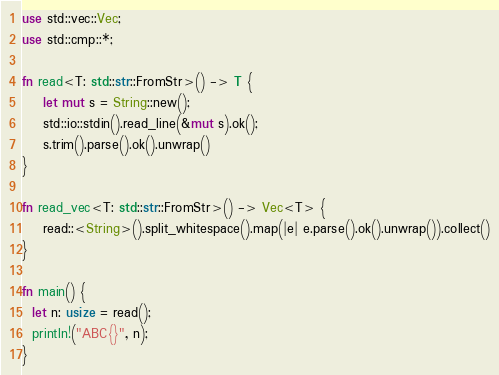<code> <loc_0><loc_0><loc_500><loc_500><_Rust_>use std::vec::Vec;
use std::cmp::*;

fn read<T: std::str::FromStr>() -> T {
    let mut s = String::new();
    std::io::stdin().read_line(&mut s).ok();
    s.trim().parse().ok().unwrap()
}

fn read_vec<T: std::str::FromStr>() -> Vec<T> {
    read::<String>().split_whitespace().map(|e| e.parse().ok().unwrap()).collect()
}

fn main() {
  let n: usize = read();
  println!("ABC{}", n);
}
</code> 